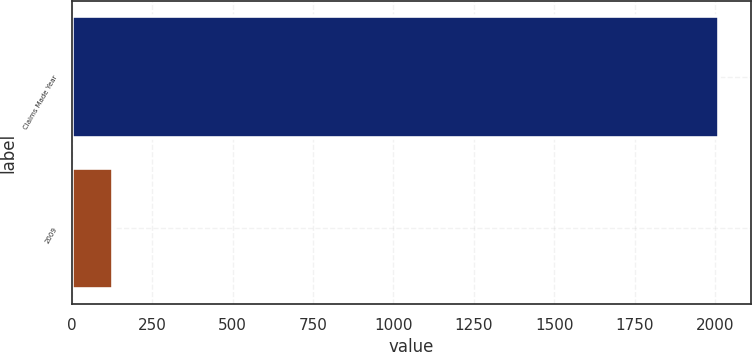<chart> <loc_0><loc_0><loc_500><loc_500><bar_chart><fcel>Claims Made Year<fcel>2009<nl><fcel>2011<fcel>127<nl></chart> 